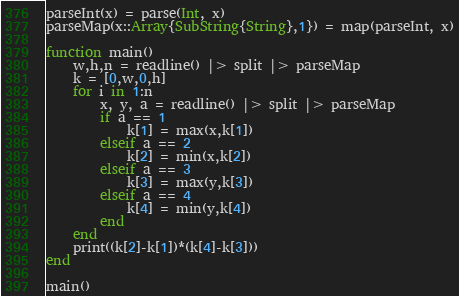Convert code to text. <code><loc_0><loc_0><loc_500><loc_500><_Julia_>parseInt(x) = parse(Int, x)
parseMap(x::Array{SubString{String},1}) = map(parseInt, x)

function main()
	w,h,n = readline() |> split |> parseMap
	k = [0,w,0,h]
	for i in 1:n
		x, y, a = readline() |> split |> parseMap
		if a == 1
			k[1] = max(x,k[1])
		elseif a == 2
			k[2] = min(x,k[2])
		elseif a == 3
			k[3] = max(y,k[3])
		elseif a == 4
			k[4] = min(y,k[4])
		end
	end
	print((k[2]-k[1])*(k[4]-k[3]))
end

main()</code> 